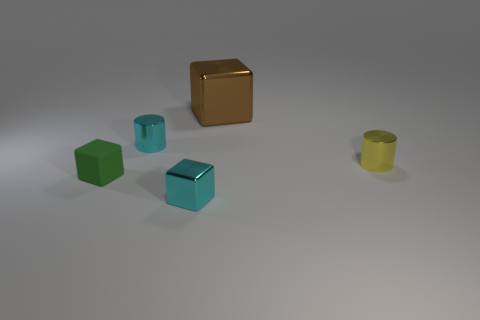What number of cyan metallic spheres are there?
Offer a terse response. 0. How many blue objects are metallic cylinders or small objects?
Give a very brief answer. 0. Are the small cylinder left of the yellow metallic thing and the tiny green object made of the same material?
Ensure brevity in your answer.  No. How many other objects are the same material as the yellow thing?
Make the answer very short. 3. What is the material of the small yellow object?
Keep it short and to the point. Metal. How big is the metallic block behind the rubber block?
Your response must be concise. Large. There is a small metallic cylinder right of the big metallic cube; what number of small cyan metallic objects are to the right of it?
Your answer should be compact. 0. Do the tiny metal thing behind the yellow metal cylinder and the object on the right side of the brown cube have the same shape?
Keep it short and to the point. Yes. What number of things are both behind the tiny cyan metal cylinder and in front of the yellow cylinder?
Your response must be concise. 0. Are there any cylinders of the same color as the tiny shiny block?
Keep it short and to the point. Yes. 